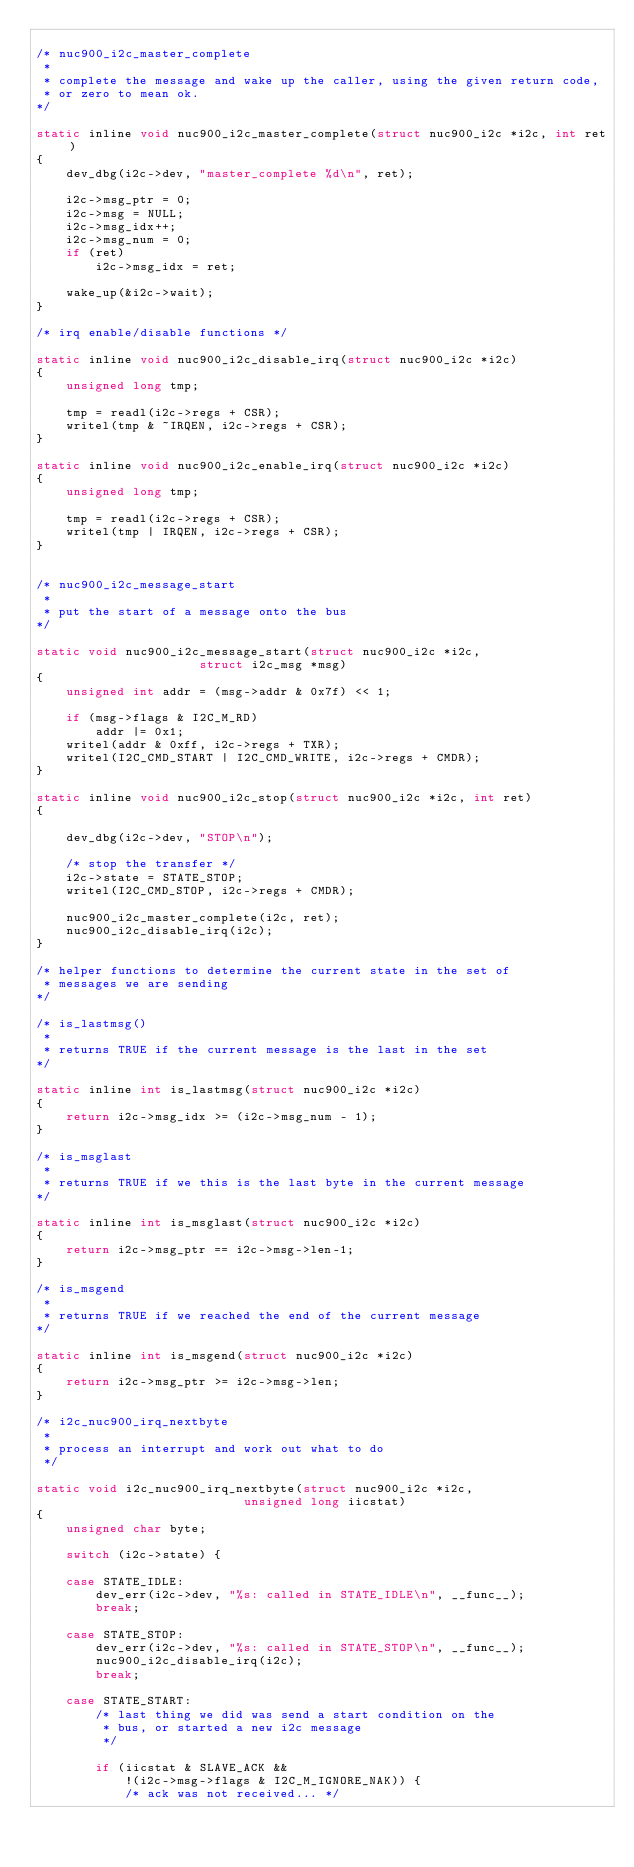<code> <loc_0><loc_0><loc_500><loc_500><_C_>
/* nuc900_i2c_master_complete
 *
 * complete the message and wake up the caller, using the given return code,
 * or zero to mean ok.
*/

static inline void nuc900_i2c_master_complete(struct nuc900_i2c *i2c, int ret)
{
	dev_dbg(i2c->dev, "master_complete %d\n", ret);

	i2c->msg_ptr = 0;
	i2c->msg = NULL;
	i2c->msg_idx++;
	i2c->msg_num = 0;
	if (ret)
		i2c->msg_idx = ret;

	wake_up(&i2c->wait);
}

/* irq enable/disable functions */

static inline void nuc900_i2c_disable_irq(struct nuc900_i2c *i2c)
{
	unsigned long tmp;

	tmp = readl(i2c->regs + CSR);
	writel(tmp & ~IRQEN, i2c->regs + CSR);
}

static inline void nuc900_i2c_enable_irq(struct nuc900_i2c *i2c)
{
	unsigned long tmp;

	tmp = readl(i2c->regs + CSR);
	writel(tmp | IRQEN, i2c->regs + CSR);
}


/* nuc900_i2c_message_start
 *
 * put the start of a message onto the bus
*/

static void nuc900_i2c_message_start(struct nuc900_i2c *i2c,
				      struct i2c_msg *msg)
{
	unsigned int addr = (msg->addr & 0x7f) << 1;

	if (msg->flags & I2C_M_RD)
		addr |= 0x1;
	writel(addr & 0xff, i2c->regs + TXR);
	writel(I2C_CMD_START | I2C_CMD_WRITE, i2c->regs + CMDR);
}

static inline void nuc900_i2c_stop(struct nuc900_i2c *i2c, int ret)
{

	dev_dbg(i2c->dev, "STOP\n");

	/* stop the transfer */
	i2c->state = STATE_STOP;
	writel(I2C_CMD_STOP, i2c->regs + CMDR);

	nuc900_i2c_master_complete(i2c, ret);
	nuc900_i2c_disable_irq(i2c);
}

/* helper functions to determine the current state in the set of
 * messages we are sending
*/

/* is_lastmsg()
 *
 * returns TRUE if the current message is the last in the set
*/

static inline int is_lastmsg(struct nuc900_i2c *i2c)
{
	return i2c->msg_idx >= (i2c->msg_num - 1);
}

/* is_msglast
 *
 * returns TRUE if we this is the last byte in the current message
*/

static inline int is_msglast(struct nuc900_i2c *i2c)
{
	return i2c->msg_ptr == i2c->msg->len-1;
}

/* is_msgend
 *
 * returns TRUE if we reached the end of the current message
*/

static inline int is_msgend(struct nuc900_i2c *i2c)
{
	return i2c->msg_ptr >= i2c->msg->len;
}

/* i2c_nuc900_irq_nextbyte
 *
 * process an interrupt and work out what to do
 */

static void i2c_nuc900_irq_nextbyte(struct nuc900_i2c *i2c,
							unsigned long iicstat)
{
	unsigned char byte;

	switch (i2c->state) {

	case STATE_IDLE:
		dev_err(i2c->dev, "%s: called in STATE_IDLE\n", __func__);
		break;

	case STATE_STOP:
		dev_err(i2c->dev, "%s: called in STATE_STOP\n", __func__);
		nuc900_i2c_disable_irq(i2c);
		break;

	case STATE_START:
		/* last thing we did was send a start condition on the
		 * bus, or started a new i2c message
		 */

		if (iicstat & SLAVE_ACK &&
		    !(i2c->msg->flags & I2C_M_IGNORE_NAK)) {
			/* ack was not received... */
</code> 